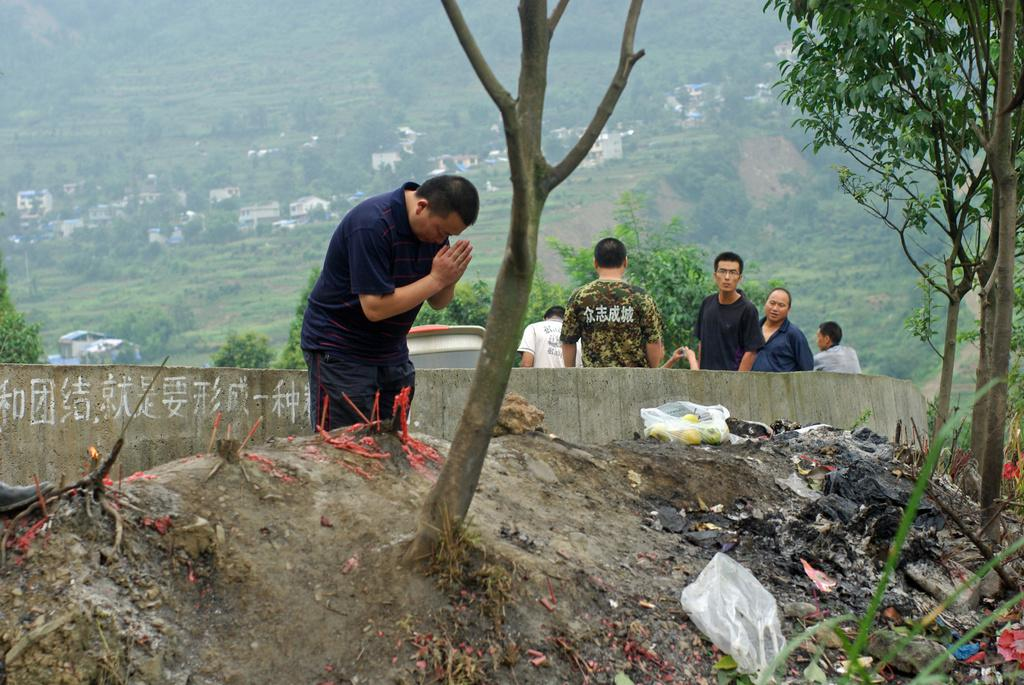How many people are in the image? There are people in the image, but the exact number is not specified. What is the man in the image doing? A man is praying in the image. What can be seen covering some objects in the image? There are covers visible in the image. What type of vegetation is present in the image? There are trees in the image. What type of structure is visible in the image? There is a wall in the image. What else can be seen in the image besides the people and the praying man? There are objects in the image. What is visible in the background of the image? There are trees and buildings in the background of the image. What type of bird is perched on the canvas in the image? There is no bird or canvas present in the image. 